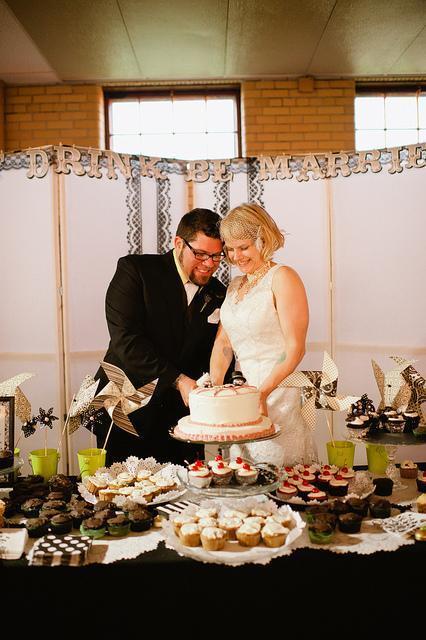How many people can you see?
Give a very brief answer. 2. How many cakes are there?
Give a very brief answer. 2. How many cars can be seen in this picture?
Give a very brief answer. 0. 